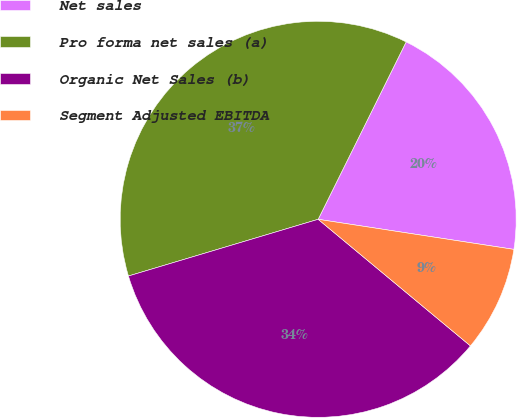Convert chart. <chart><loc_0><loc_0><loc_500><loc_500><pie_chart><fcel>Net sales<fcel>Pro forma net sales (a)<fcel>Organic Net Sales (b)<fcel>Segment Adjusted EBITDA<nl><fcel>20.1%<fcel>36.95%<fcel>34.34%<fcel>8.61%<nl></chart> 